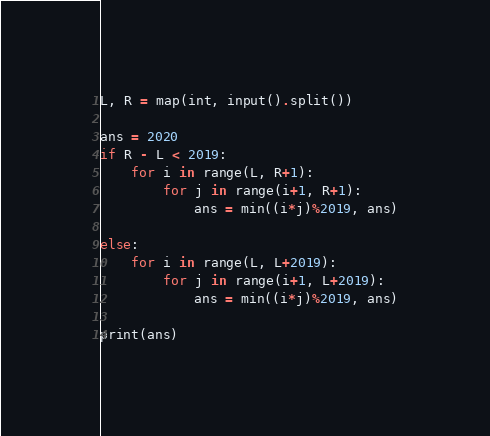Convert code to text. <code><loc_0><loc_0><loc_500><loc_500><_Python_>L, R = map(int, input().split())

ans = 2020
if R - L < 2019:
    for i in range(L, R+1):
        for j in range(i+1, R+1):
            ans = min((i*j)%2019, ans)

else:
    for i in range(L, L+2019):
        for j in range(i+1, L+2019):
            ans = min((i*j)%2019, ans)

print(ans)
</code> 